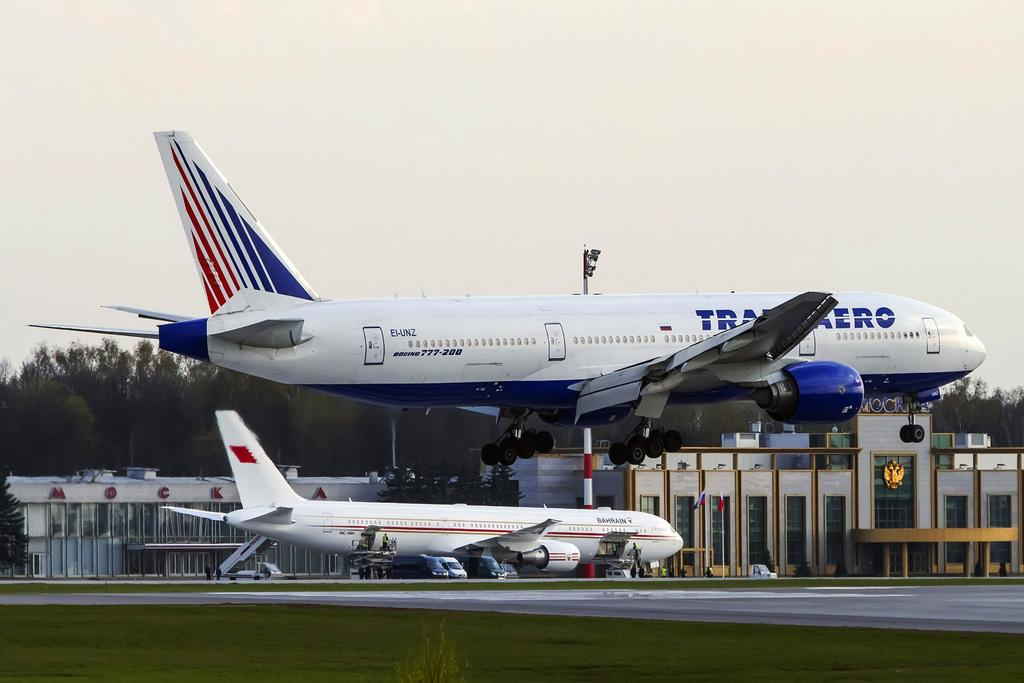<image>
Present a compact description of the photo's key features. Two airplanes on the runway where EI-UN2 is taking off into the air and a Bahrain plane below. 